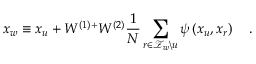<formula> <loc_0><loc_0><loc_500><loc_500>x _ { w } \equiv x _ { u } + W ^ { ( 1 ) + } W ^ { ( 2 ) } \frac { 1 } { N } \sum _ { r \in \mathcal { Z } _ { w } \ u } \psi \left ( x _ { u } , x _ { r } \right ) \quad .</formula> 